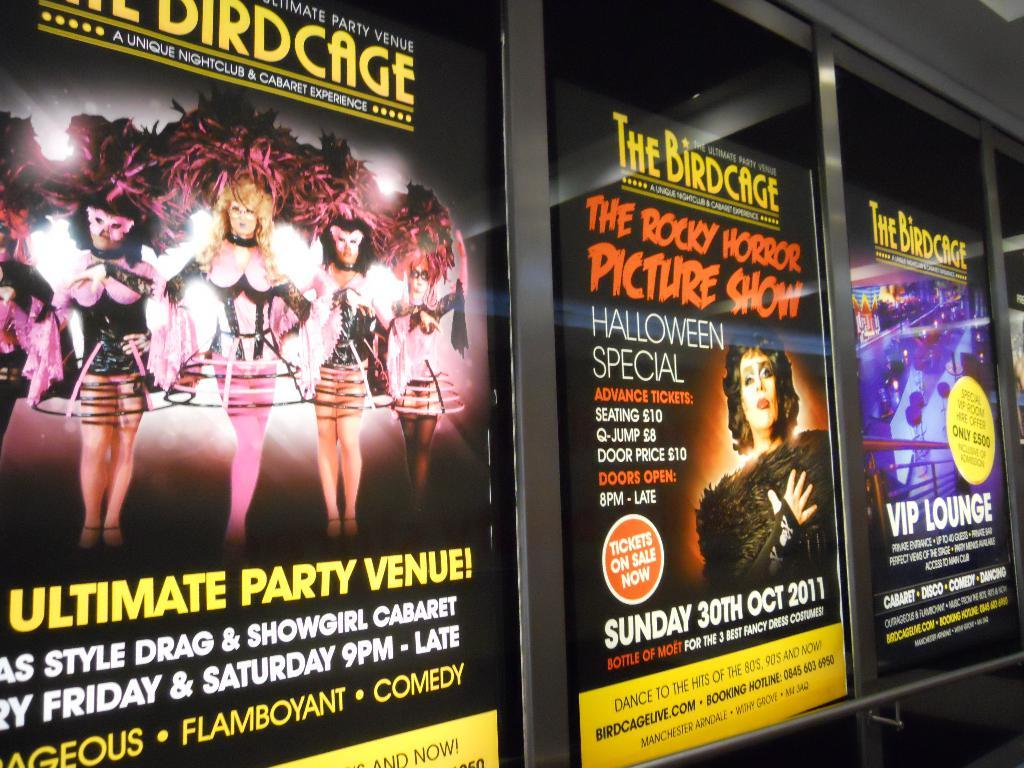Provide a one-sentence caption for the provided image. Three posters in a row showing The Birdcage showings. 